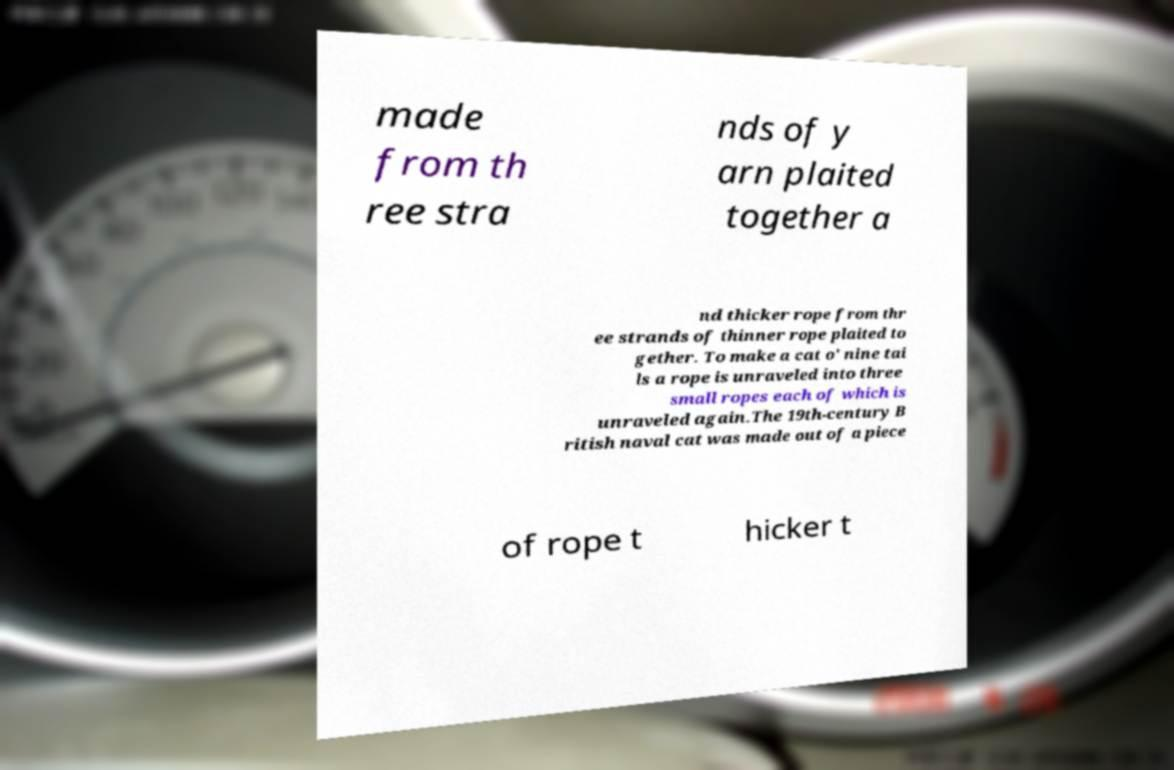There's text embedded in this image that I need extracted. Can you transcribe it verbatim? made from th ree stra nds of y arn plaited together a nd thicker rope from thr ee strands of thinner rope plaited to gether. To make a cat o' nine tai ls a rope is unraveled into three small ropes each of which is unraveled again.The 19th-century B ritish naval cat was made out of a piece of rope t hicker t 